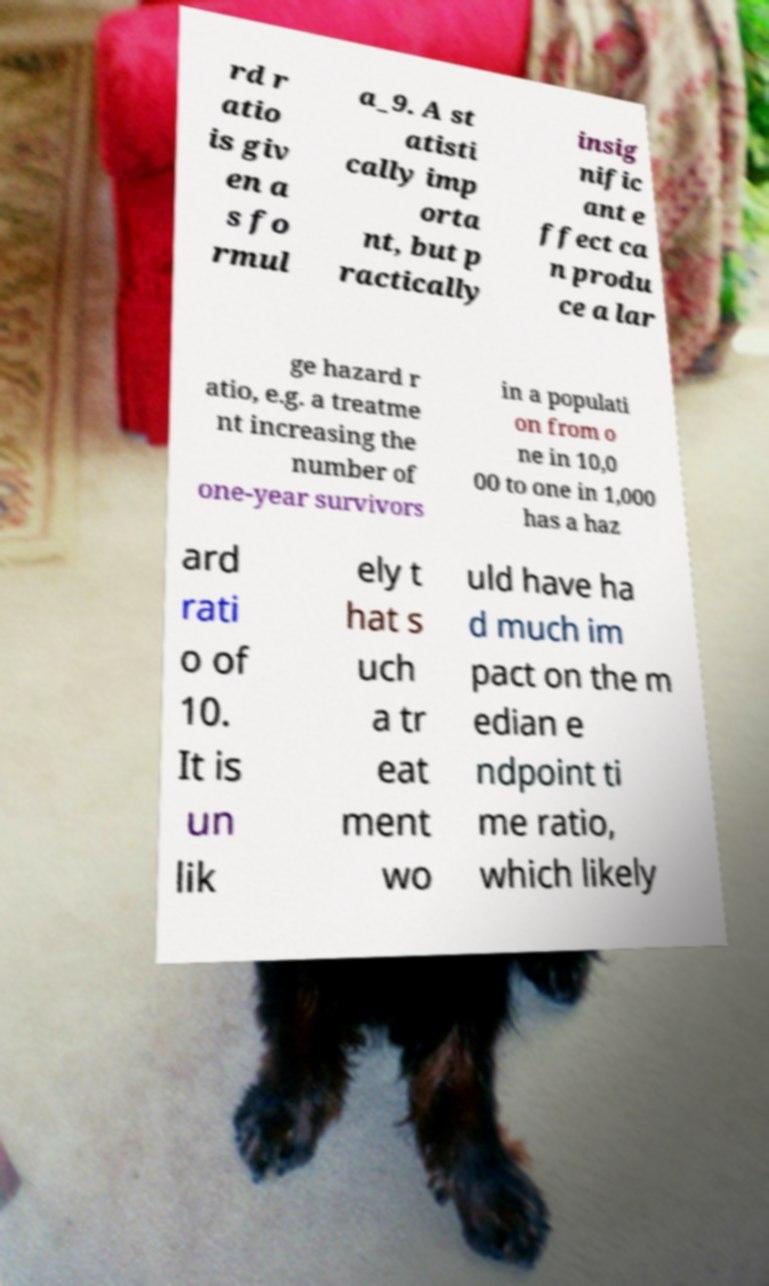For documentation purposes, I need the text within this image transcribed. Could you provide that? rd r atio is giv en a s fo rmul a_9. A st atisti cally imp orta nt, but p ractically insig nific ant e ffect ca n produ ce a lar ge hazard r atio, e.g. a treatme nt increasing the number of one-year survivors in a populati on from o ne in 10,0 00 to one in 1,000 has a haz ard rati o of 10. It is un lik ely t hat s uch a tr eat ment wo uld have ha d much im pact on the m edian e ndpoint ti me ratio, which likely 